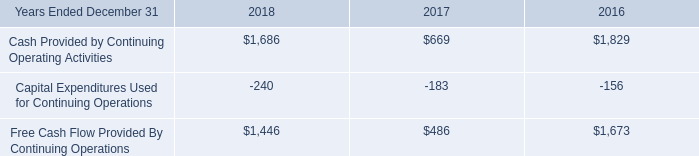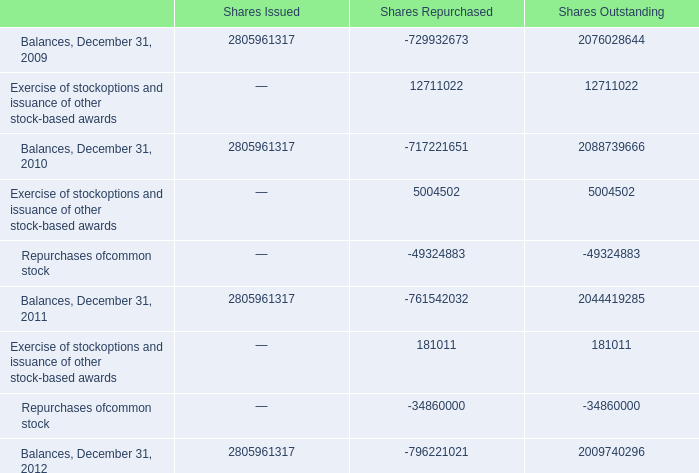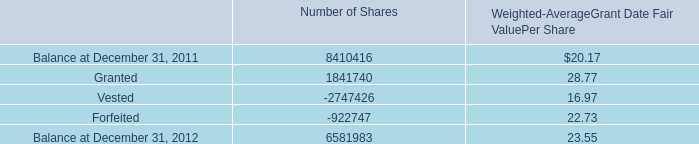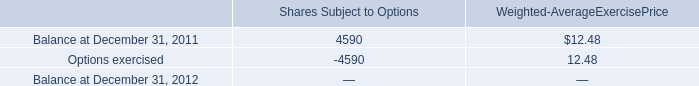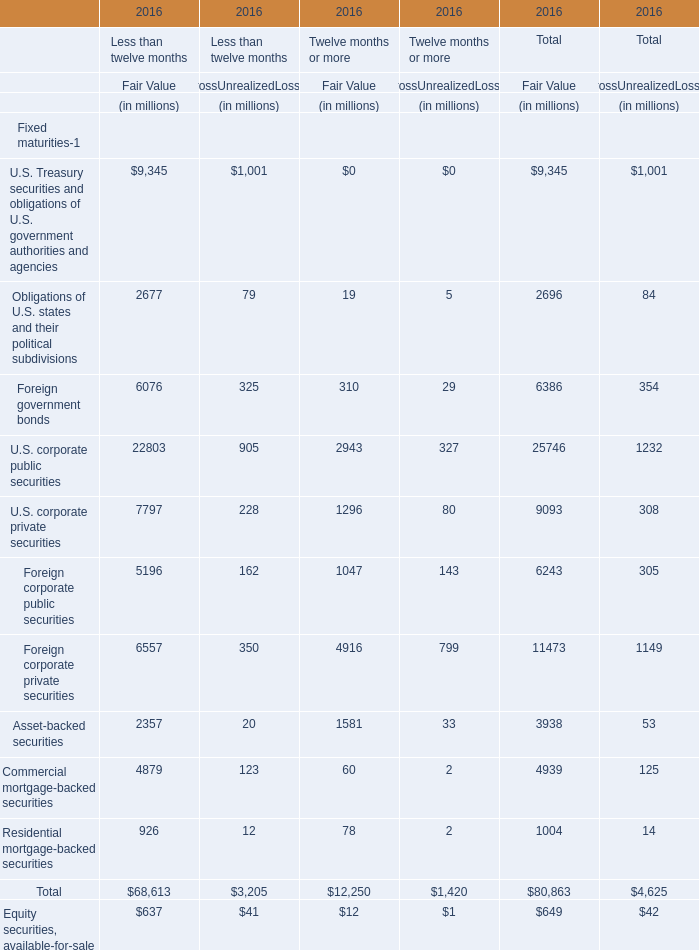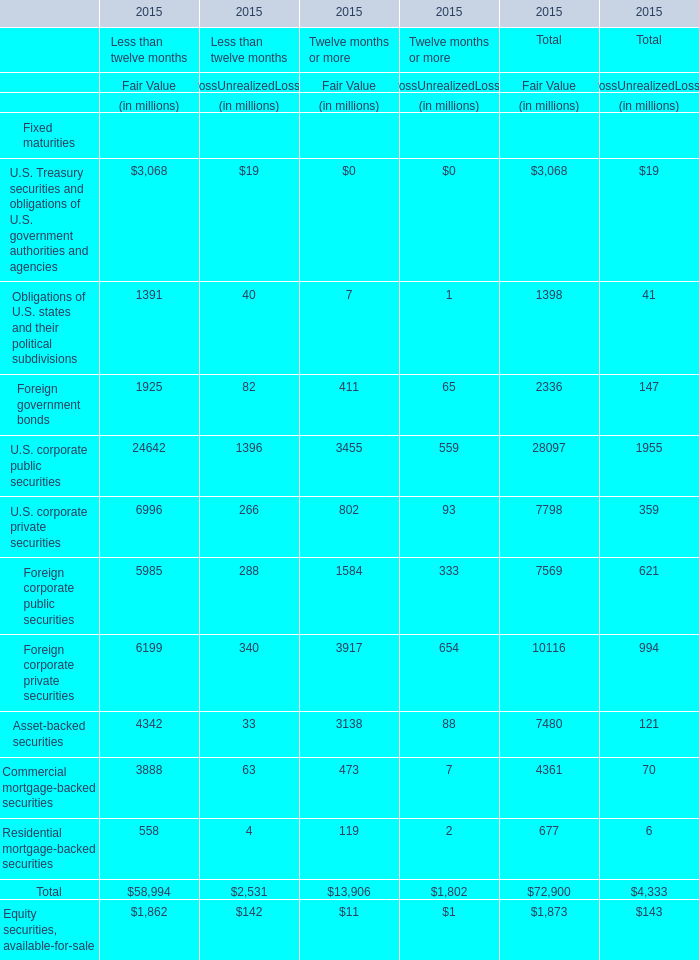what is the highest total amount of Foreign corporate private securities for GrossUnrealizedLosses? (in milion) 
Computations: (340 + 654)
Answer: 994.0. 